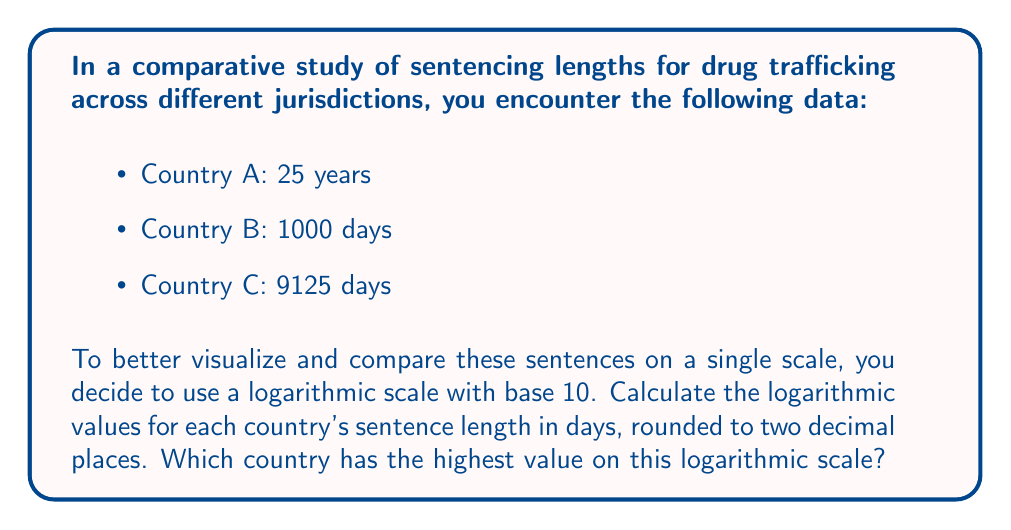Can you answer this question? To solve this problem, we need to follow these steps:

1. Convert all sentences to days:
   Country A: 25 years = 25 * 365 = 9125 days
   Country B: 1000 days (already in days)
   Country C: 9125 days (already in days)

2. Calculate the logarithm (base 10) for each country's sentence:

   For Country A:
   $$\log_{10}(9125) \approx 3.96$$

   For Country B:
   $$\log_{10}(1000) = 3$$

   For Country C:
   $$\log_{10}(9125) \approx 3.96$$

3. Round each result to two decimal places:
   Country A: 3.96
   Country B: 3.00
   Country C: 3.96

4. Compare the values to determine which country has the highest value on the logarithmic scale:
   Countries A and C have the highest value at 3.96.
Answer: Countries A and C (3.96) 